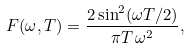<formula> <loc_0><loc_0><loc_500><loc_500>F ( \omega , T ) = \frac { 2 \sin ^ { 2 } ( \omega T / 2 ) } { \pi T \, \omega ^ { 2 } } ,</formula> 